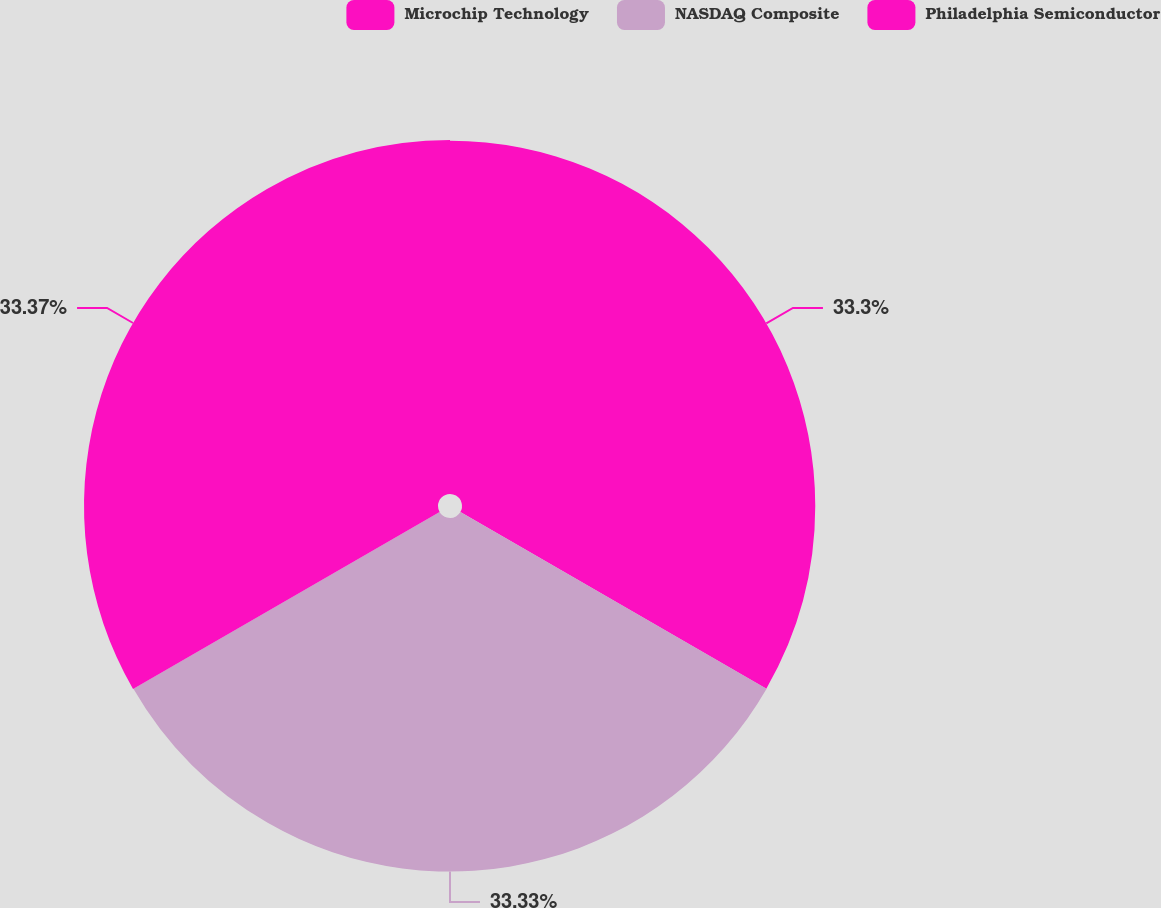<chart> <loc_0><loc_0><loc_500><loc_500><pie_chart><fcel>Microchip Technology<fcel>NASDAQ Composite<fcel>Philadelphia Semiconductor<nl><fcel>33.3%<fcel>33.33%<fcel>33.37%<nl></chart> 